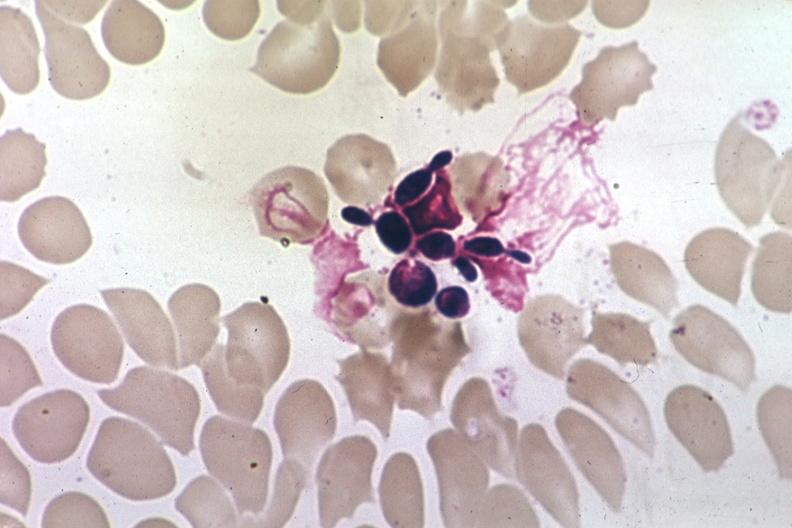does thymus show wrights budding yeast forms?
Answer the question using a single word or phrase. No 